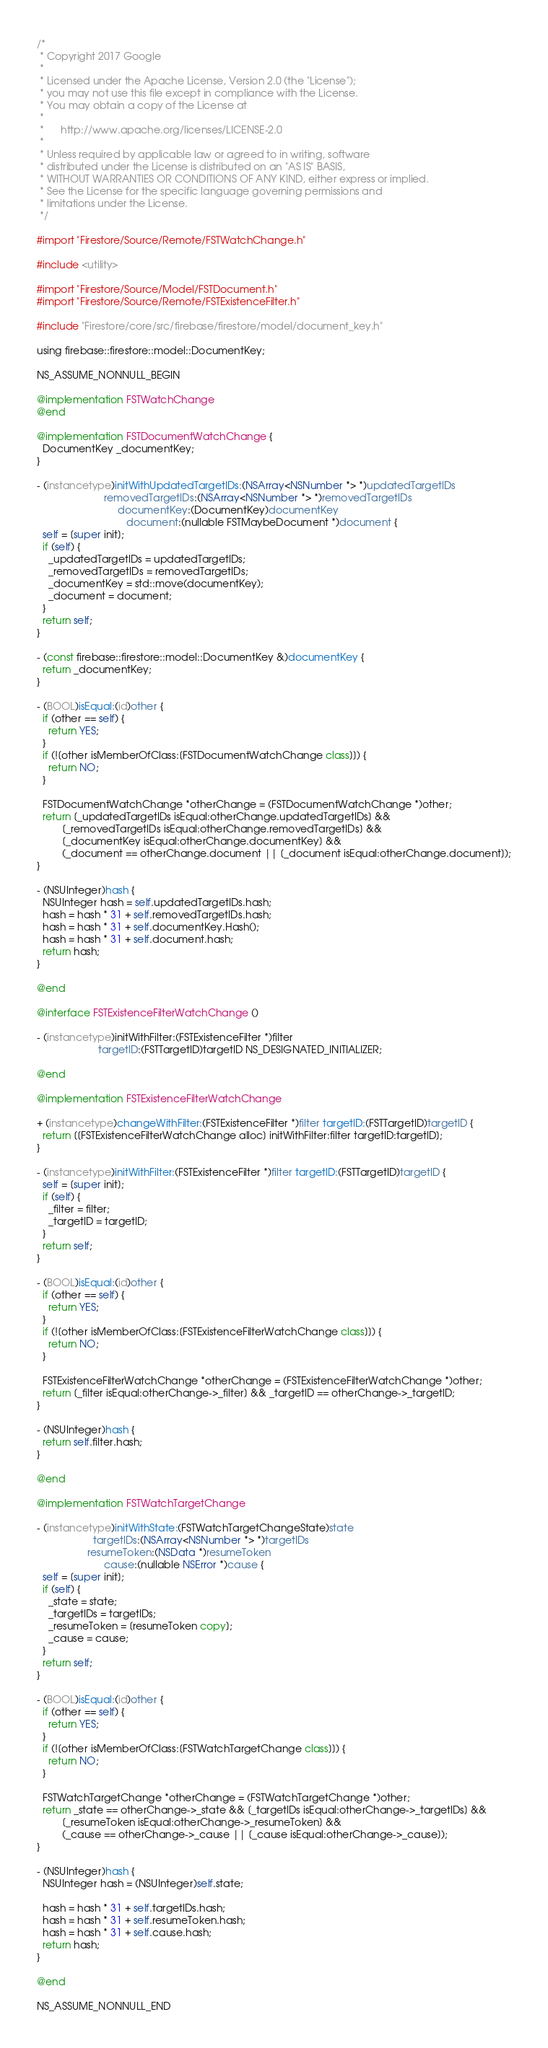Convert code to text. <code><loc_0><loc_0><loc_500><loc_500><_ObjectiveC_>/*
 * Copyright 2017 Google
 *
 * Licensed under the Apache License, Version 2.0 (the "License");
 * you may not use this file except in compliance with the License.
 * You may obtain a copy of the License at
 *
 *      http://www.apache.org/licenses/LICENSE-2.0
 *
 * Unless required by applicable law or agreed to in writing, software
 * distributed under the License is distributed on an "AS IS" BASIS,
 * WITHOUT WARRANTIES OR CONDITIONS OF ANY KIND, either express or implied.
 * See the License for the specific language governing permissions and
 * limitations under the License.
 */

#import "Firestore/Source/Remote/FSTWatchChange.h"

#include <utility>

#import "Firestore/Source/Model/FSTDocument.h"
#import "Firestore/Source/Remote/FSTExistenceFilter.h"

#include "Firestore/core/src/firebase/firestore/model/document_key.h"

using firebase::firestore::model::DocumentKey;

NS_ASSUME_NONNULL_BEGIN

@implementation FSTWatchChange
@end

@implementation FSTDocumentWatchChange {
  DocumentKey _documentKey;
}

- (instancetype)initWithUpdatedTargetIDs:(NSArray<NSNumber *> *)updatedTargetIDs
                        removedTargetIDs:(NSArray<NSNumber *> *)removedTargetIDs
                             documentKey:(DocumentKey)documentKey
                                document:(nullable FSTMaybeDocument *)document {
  self = [super init];
  if (self) {
    _updatedTargetIDs = updatedTargetIDs;
    _removedTargetIDs = removedTargetIDs;
    _documentKey = std::move(documentKey);
    _document = document;
  }
  return self;
}

- (const firebase::firestore::model::DocumentKey &)documentKey {
  return _documentKey;
}

- (BOOL)isEqual:(id)other {
  if (other == self) {
    return YES;
  }
  if (![other isMemberOfClass:[FSTDocumentWatchChange class]]) {
    return NO;
  }

  FSTDocumentWatchChange *otherChange = (FSTDocumentWatchChange *)other;
  return [_updatedTargetIDs isEqual:otherChange.updatedTargetIDs] &&
         [_removedTargetIDs isEqual:otherChange.removedTargetIDs] &&
         [_documentKey isEqual:otherChange.documentKey] &&
         (_document == otherChange.document || [_document isEqual:otherChange.document]);
}

- (NSUInteger)hash {
  NSUInteger hash = self.updatedTargetIDs.hash;
  hash = hash * 31 + self.removedTargetIDs.hash;
  hash = hash * 31 + self.documentKey.Hash();
  hash = hash * 31 + self.document.hash;
  return hash;
}

@end

@interface FSTExistenceFilterWatchChange ()

- (instancetype)initWithFilter:(FSTExistenceFilter *)filter
                      targetID:(FSTTargetID)targetID NS_DESIGNATED_INITIALIZER;

@end

@implementation FSTExistenceFilterWatchChange

+ (instancetype)changeWithFilter:(FSTExistenceFilter *)filter targetID:(FSTTargetID)targetID {
  return [[FSTExistenceFilterWatchChange alloc] initWithFilter:filter targetID:targetID];
}

- (instancetype)initWithFilter:(FSTExistenceFilter *)filter targetID:(FSTTargetID)targetID {
  self = [super init];
  if (self) {
    _filter = filter;
    _targetID = targetID;
  }
  return self;
}

- (BOOL)isEqual:(id)other {
  if (other == self) {
    return YES;
  }
  if (![other isMemberOfClass:[FSTExistenceFilterWatchChange class]]) {
    return NO;
  }

  FSTExistenceFilterWatchChange *otherChange = (FSTExistenceFilterWatchChange *)other;
  return [_filter isEqual:otherChange->_filter] && _targetID == otherChange->_targetID;
}

- (NSUInteger)hash {
  return self.filter.hash;
}

@end

@implementation FSTWatchTargetChange

- (instancetype)initWithState:(FSTWatchTargetChangeState)state
                    targetIDs:(NSArray<NSNumber *> *)targetIDs
                  resumeToken:(NSData *)resumeToken
                        cause:(nullable NSError *)cause {
  self = [super init];
  if (self) {
    _state = state;
    _targetIDs = targetIDs;
    _resumeToken = [resumeToken copy];
    _cause = cause;
  }
  return self;
}

- (BOOL)isEqual:(id)other {
  if (other == self) {
    return YES;
  }
  if (![other isMemberOfClass:[FSTWatchTargetChange class]]) {
    return NO;
  }

  FSTWatchTargetChange *otherChange = (FSTWatchTargetChange *)other;
  return _state == otherChange->_state && [_targetIDs isEqual:otherChange->_targetIDs] &&
         [_resumeToken isEqual:otherChange->_resumeToken] &&
         (_cause == otherChange->_cause || [_cause isEqual:otherChange->_cause]);
}

- (NSUInteger)hash {
  NSUInteger hash = (NSUInteger)self.state;

  hash = hash * 31 + self.targetIDs.hash;
  hash = hash * 31 + self.resumeToken.hash;
  hash = hash * 31 + self.cause.hash;
  return hash;
}

@end

NS_ASSUME_NONNULL_END
</code> 